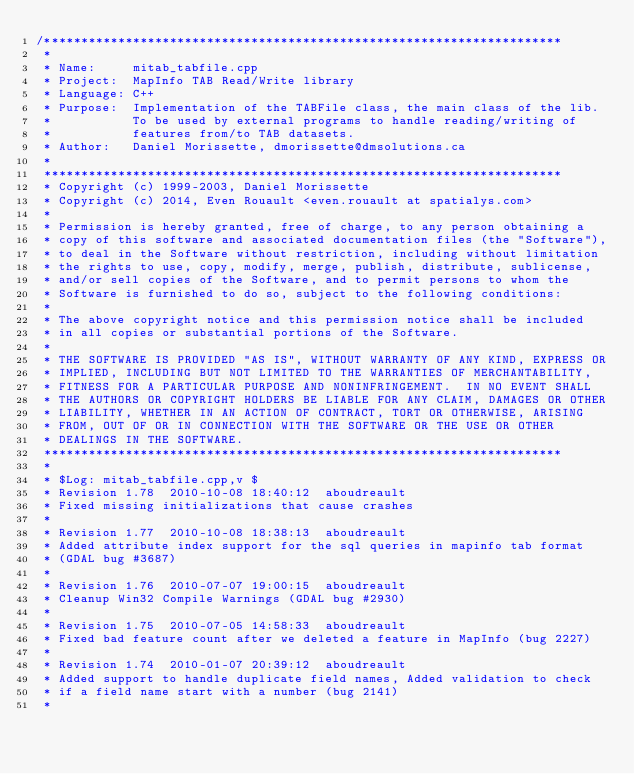Convert code to text. <code><loc_0><loc_0><loc_500><loc_500><_C++_>/**********************************************************************
 *
 * Name:     mitab_tabfile.cpp
 * Project:  MapInfo TAB Read/Write library
 * Language: C++
 * Purpose:  Implementation of the TABFile class, the main class of the lib.
 *           To be used by external programs to handle reading/writing of
 *           features from/to TAB datasets.
 * Author:   Daniel Morissette, dmorissette@dmsolutions.ca
 *
 **********************************************************************
 * Copyright (c) 1999-2003, Daniel Morissette
 * Copyright (c) 2014, Even Rouault <even.rouault at spatialys.com>
 *
 * Permission is hereby granted, free of charge, to any person obtaining a
 * copy of this software and associated documentation files (the "Software"),
 * to deal in the Software without restriction, including without limitation
 * the rights to use, copy, modify, merge, publish, distribute, sublicense,
 * and/or sell copies of the Software, and to permit persons to whom the
 * Software is furnished to do so, subject to the following conditions:
 *
 * The above copyright notice and this permission notice shall be included
 * in all copies or substantial portions of the Software.
 *
 * THE SOFTWARE IS PROVIDED "AS IS", WITHOUT WARRANTY OF ANY KIND, EXPRESS OR
 * IMPLIED, INCLUDING BUT NOT LIMITED TO THE WARRANTIES OF MERCHANTABILITY,
 * FITNESS FOR A PARTICULAR PURPOSE AND NONINFRINGEMENT.  IN NO EVENT SHALL
 * THE AUTHORS OR COPYRIGHT HOLDERS BE LIABLE FOR ANY CLAIM, DAMAGES OR OTHER
 * LIABILITY, WHETHER IN AN ACTION OF CONTRACT, TORT OR OTHERWISE, ARISING
 * FROM, OUT OF OR IN CONNECTION WITH THE SOFTWARE OR THE USE OR OTHER
 * DEALINGS IN THE SOFTWARE.
 **********************************************************************
 *
 * $Log: mitab_tabfile.cpp,v $
 * Revision 1.78  2010-10-08 18:40:12  aboudreault
 * Fixed missing initializations that cause crashes
 *
 * Revision 1.77  2010-10-08 18:38:13  aboudreault
 * Added attribute index support for the sql queries in mapinfo tab format
 * (GDAL bug #3687)
 *
 * Revision 1.76  2010-07-07 19:00:15  aboudreault
 * Cleanup Win32 Compile Warnings (GDAL bug #2930)
 *
 * Revision 1.75  2010-07-05 14:58:33  aboudreault
 * Fixed bad feature count after we deleted a feature in MapInfo (bug 2227)
 *
 * Revision 1.74  2010-01-07 20:39:12  aboudreault
 * Added support to handle duplicate field names, Added validation to check
 * if a field name start with a number (bug 2141)
 *</code> 